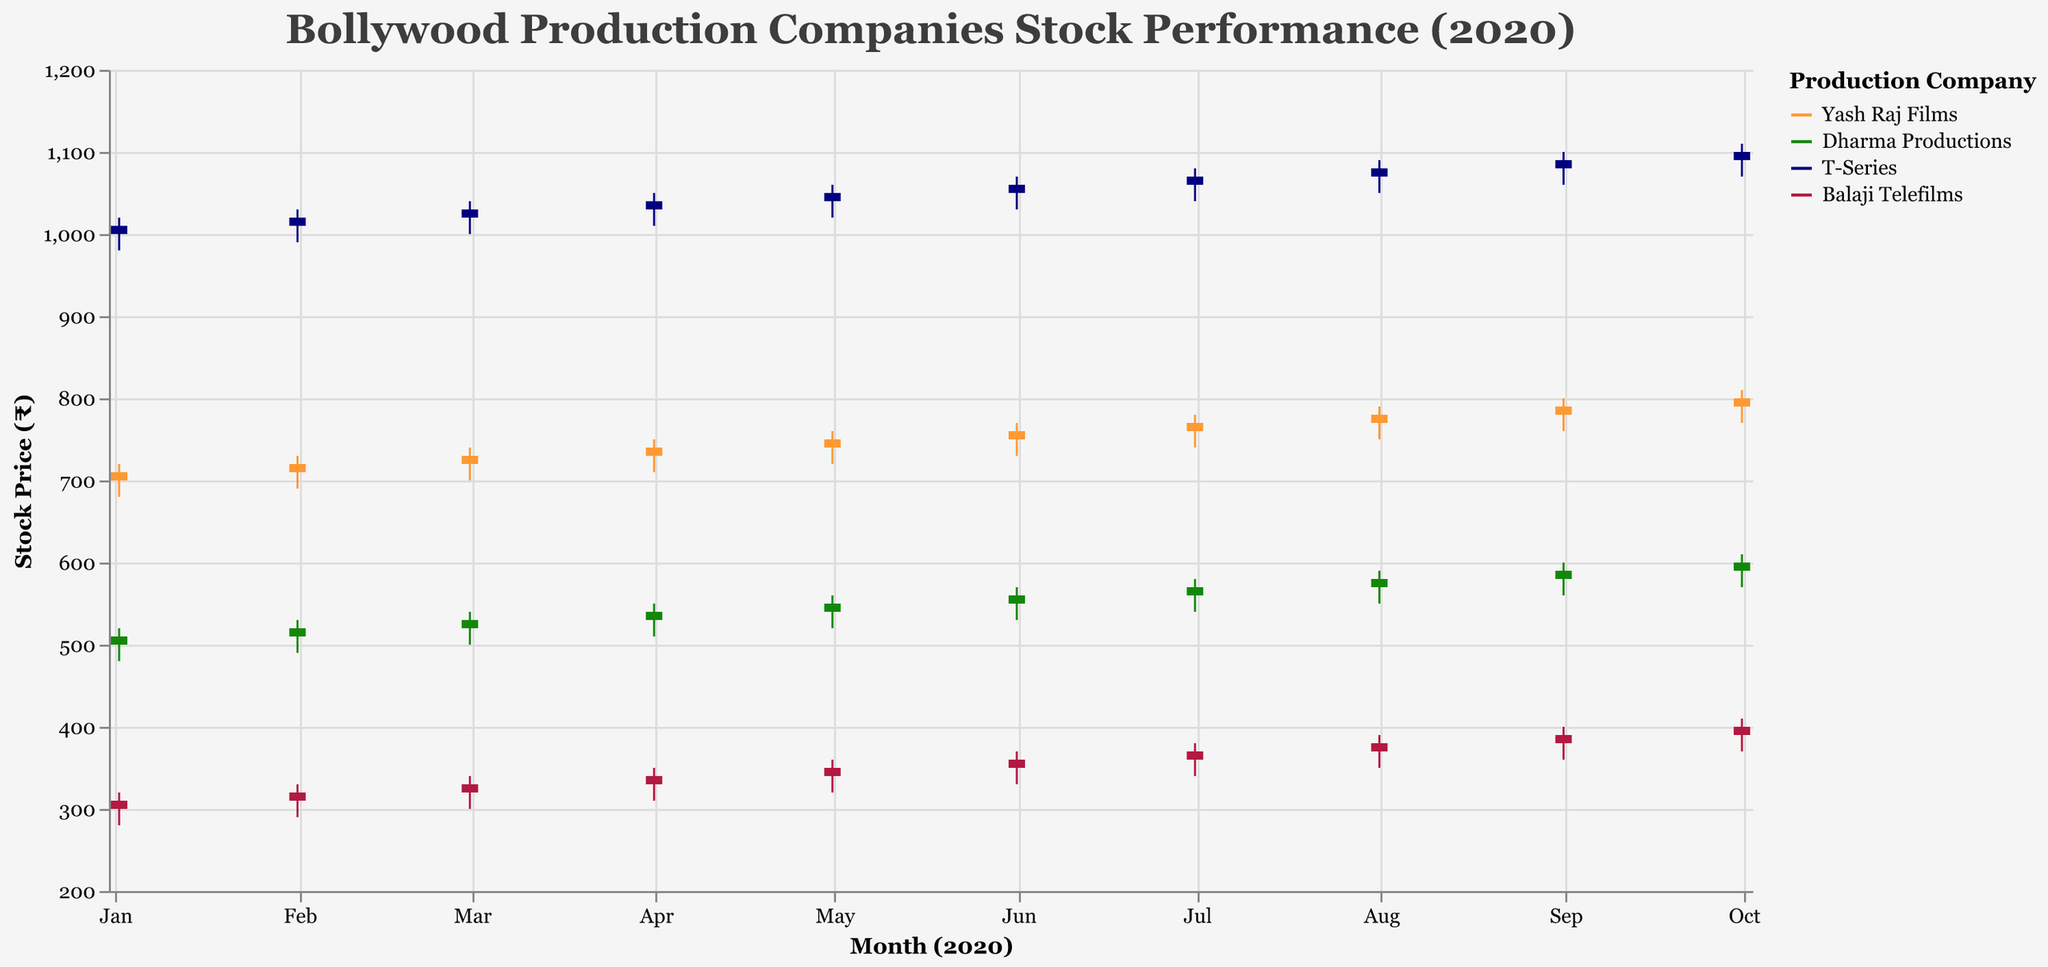What is the title of the figure? The title is located at the top of the figure and provides a summary of what the figure represents. The title here is "Bollywood Production Companies Stock Performance (2020)".
Answer: Bollywood Production Companies Stock Performance (2020) Which company has the highest closing stock price in October 2020? Look for the bar that reaches the highest point on the y-axis labeled "Close" for October 2020. T-Series has a closing stock price of ₹1100 in October, which is the highest.
Answer: T-Series Which month shows the lowest closing price for Balaji Telefilms? Find the company "Balaji Telefilms" in the legend, then follow the bars for each month to find the lowest "Close" value. The lowest closing price occurs in January with a value of ₹310.
Answer: January What is the approximate range of stock prices for Dharma Productions in July 2020? For July 2020, identify the High and Low prices for Dharma Productions. They are shown as the endpoints of the vertical lines. The High is ₹580 and the Low is ₹540, calculating the range as 580 - 540.
Answer: ₹40 Between Yash Raj Films and Dharma Productions, which company exhibited a greater increase in closing stock price from January to October 2020? Calculate the difference in the "Close" prices between October and January for both companies. Yash Raj Films: ₹800 (Oct) - ₹710 (Jan) = ₹90. Dharma Productions: ₹600 (Oct) - ₹510 (Jan) = ₹90. Both companies show an equal increase.
Answer: Both companies What is the average closing stock price for T-Series in the first quarter of 2020 (January to March)? Sum the closing prices for January, February, and March for T-Series, and divide by the number of months. \( (₹1010 + ₹1020 + ₹1030) / 3 = ₹1020 \)
Answer: ₹1020 Which company has the most consistent growth in stock price from January to October 2020? Check each company's closing stock prices. An evenly increasing pattern across months indicates consistency. T-Series shows a steady increase without any dips.
Answer: T-Series How much did the closing stock price for Balaji Telefilms change from the start to the end of 2020? Find the difference in the closing stock price of Balaji Telefilms between October and January. \( ₹400 (Oct) - ₹310 (Jan) = ₹90 \)
Answer: ₹90 Which company had the highest volatility in stock prices in August 2020? Check the range (High - Low) for each company in August 2020. T-Series shows the highest range (₹1090 - ₹1050 = ₹40).
Answer: T-Series How did the stock price trend for Dharma Productions change over the year 2020? Observe the "Close" values for Dharma Productions from January to October. There is a consistent increase each month with no significant drops, indicating a steady upward trend.
Answer: Consistent upward trend 